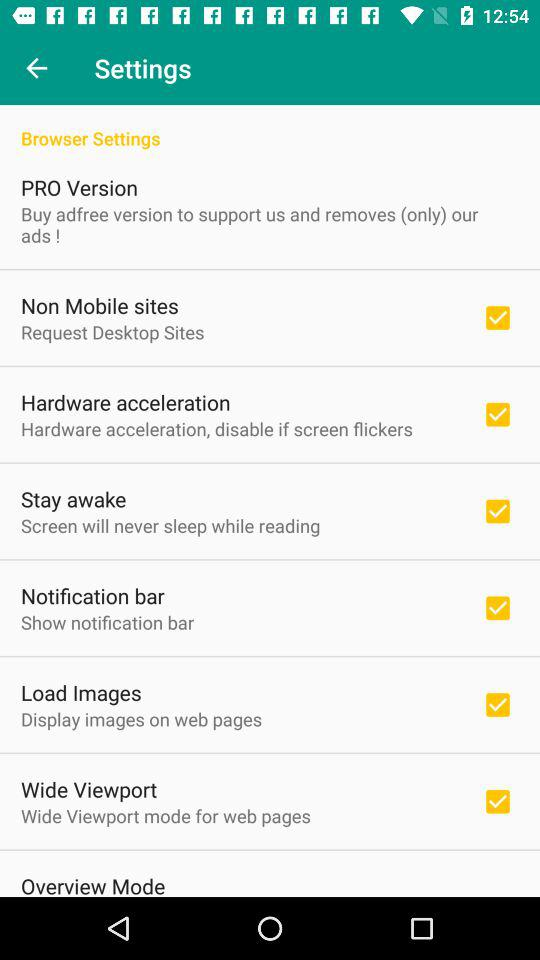What is the status of the "Wide Viewport" setting option? The status is on. 